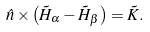<formula> <loc_0><loc_0><loc_500><loc_500>\hat { n } \times \left ( \vec { H } _ { \alpha } - \vec { H } _ { \beta } \right ) = \vec { K } .</formula> 